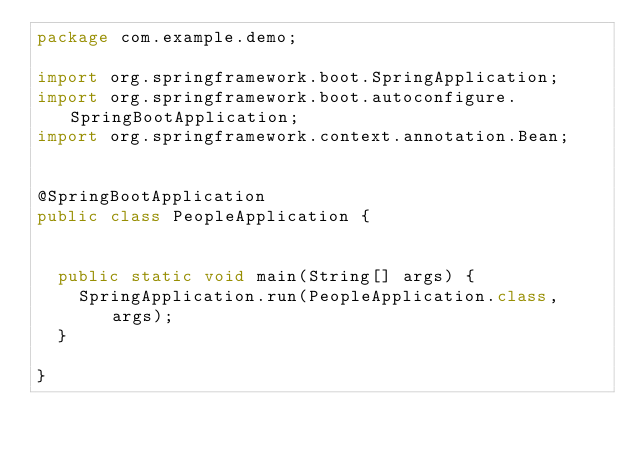<code> <loc_0><loc_0><loc_500><loc_500><_Java_>package com.example.demo;

import org.springframework.boot.SpringApplication;
import org.springframework.boot.autoconfigure.SpringBootApplication;
import org.springframework.context.annotation.Bean;


@SpringBootApplication
public class PeopleApplication {
 
	
	public static void main(String[] args) {
		SpringApplication.run(PeopleApplication.class, args);
	}

}
</code> 